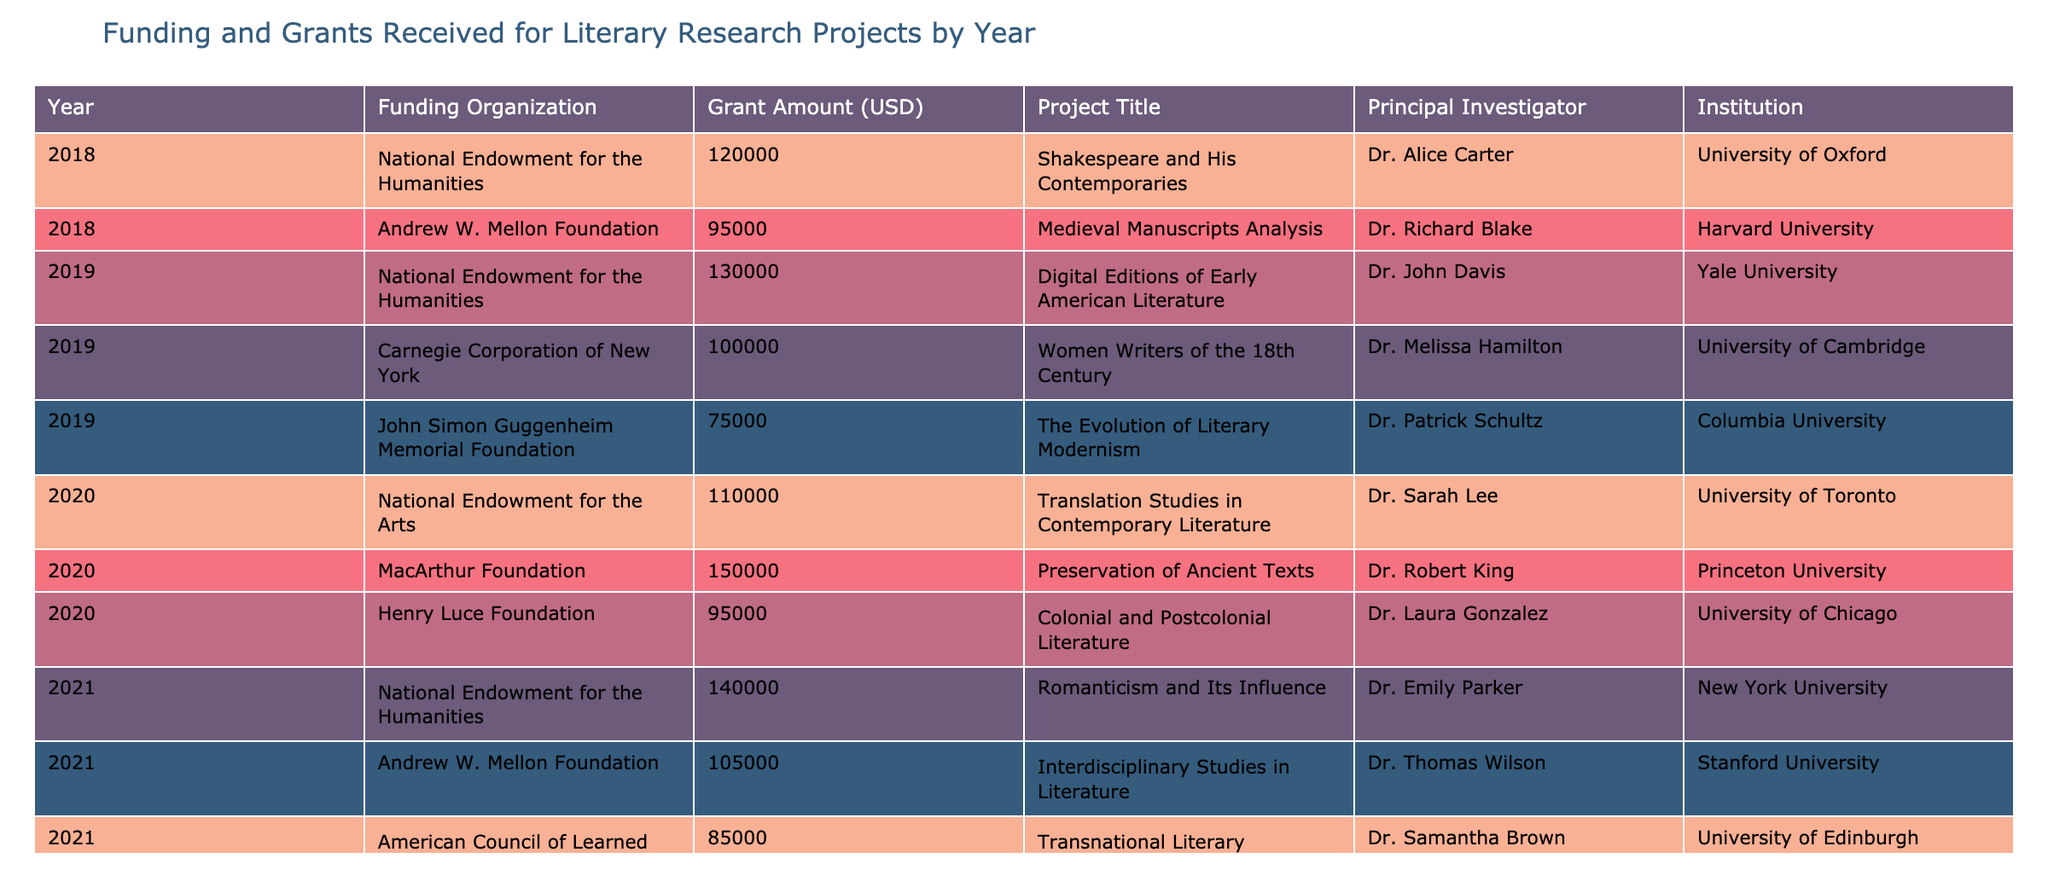What was the total grant amount received in 2019? To find the total grant amount for 2019, I need to sum the grant amounts for all entries from that year: 130000 + 100000 + 75000 = 305000.
Answer: 305000 Which institution received the highest grant amount in 2020? In 2020, the grants were received by three institutions with amounts of 110000, 150000, and 95000. The highest amount is 150000 which was awarded to Princeton University.
Answer: Princeton University Was there any project in 2022 funded by the Andrew W. Mellon Foundation? Looking through the 2022 row, it's clear that there are grants from the National Endowment for the Arts, Carnegie Corporation of New York, and John Simon Guggenheim Memorial Foundation, but none from the Andrew W. Mellon Foundation.
Answer: No What is the average grant amount across all years listed? To find the average, I need to sum all the grant amounts: 120000 + 95000 + 130000 + 100000 + 75000 + 110000 + 150000 + 95000 + 140000 + 105000 + 85000 + 115000 + 120000 + 80000 = 1435000. There are 13 grants in total, so the average is 1435000 / 13 = 110384.62.
Answer: 110384.62 Which year had the lowest total grant funding? I need to first calculate the total grant funding for each year: 2018 = 215000, 2019 = 305000, 2020 = 305000, 2021 = 330000, 2022 = 320000. The year with the lowest total is 2018 with 215000.
Answer: 2018 